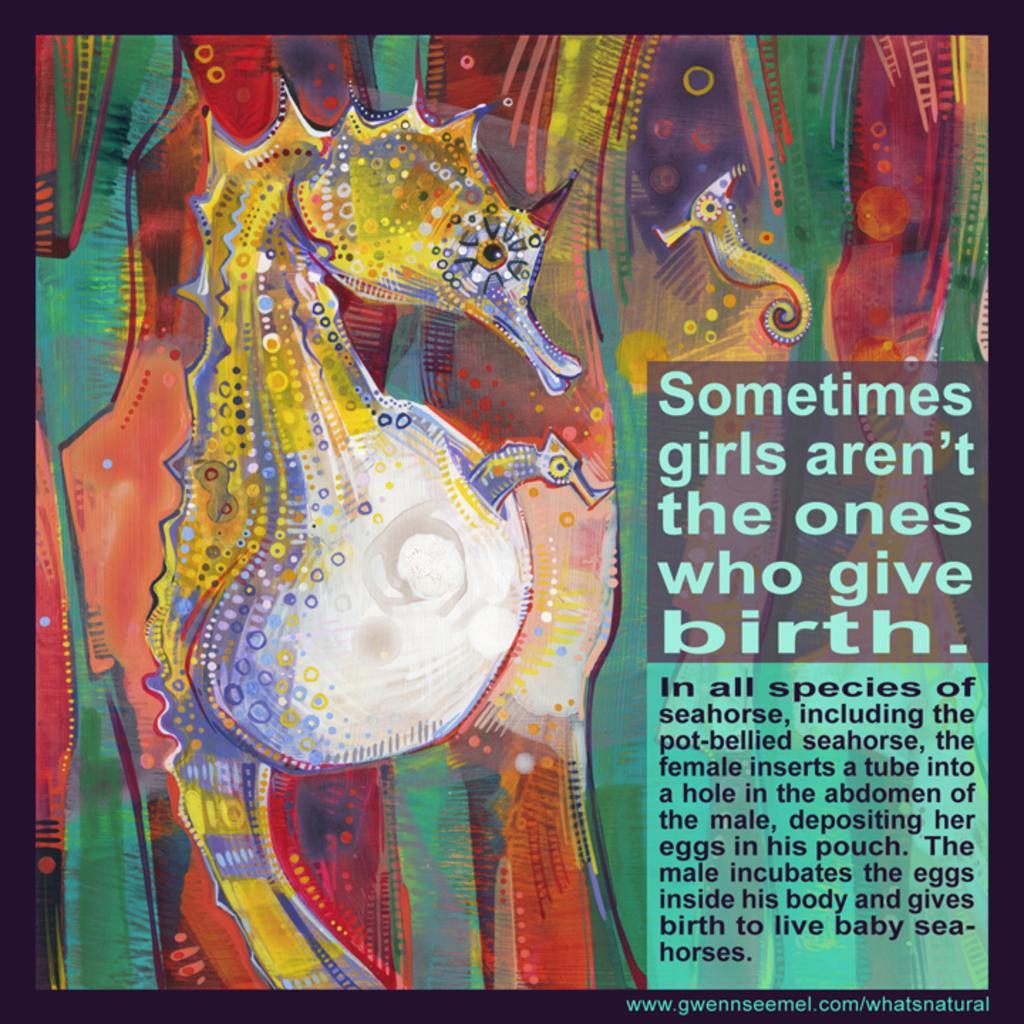Could you give a brief overview of what you see in this image? In this image it seems like an art in which there is a dragon sea horse on the left side and some text on the right side. 